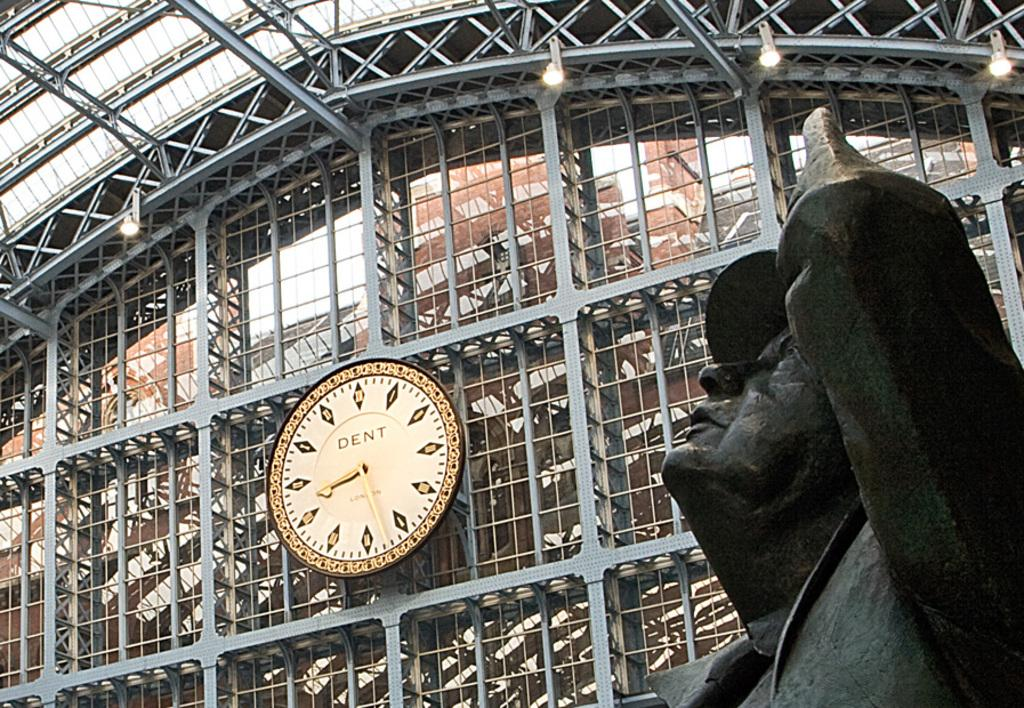<image>
Relay a brief, clear account of the picture shown. Statue and a gold clock with the time and dent wrote on it 